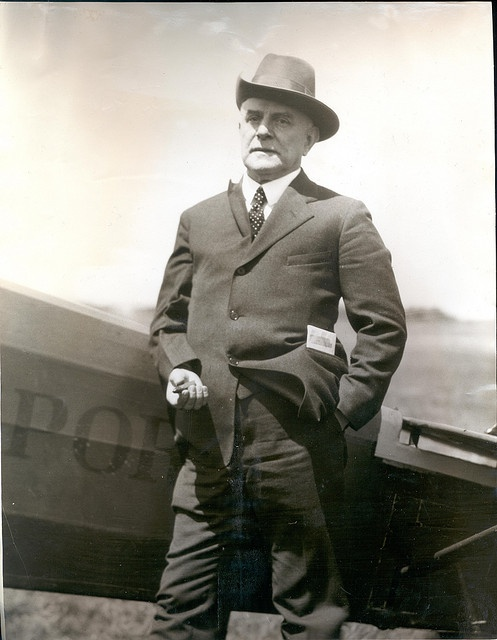Describe the objects in this image and their specific colors. I can see people in navy, black, gray, and darkgray tones, airplane in navy, black, gray, and darkgray tones, and tie in navy, gray, darkgray, and black tones in this image. 